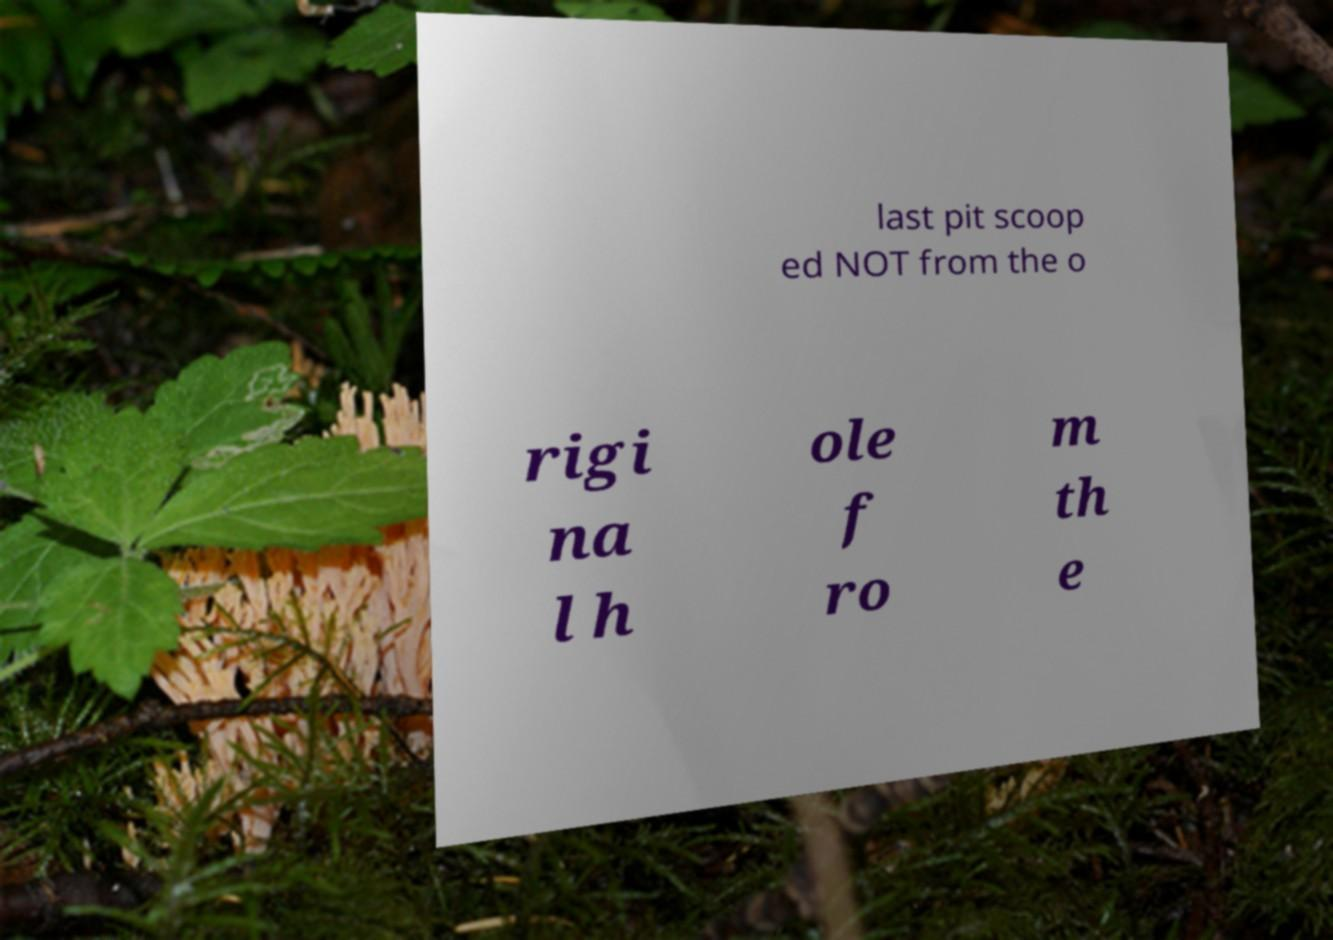Could you assist in decoding the text presented in this image and type it out clearly? last pit scoop ed NOT from the o rigi na l h ole f ro m th e 